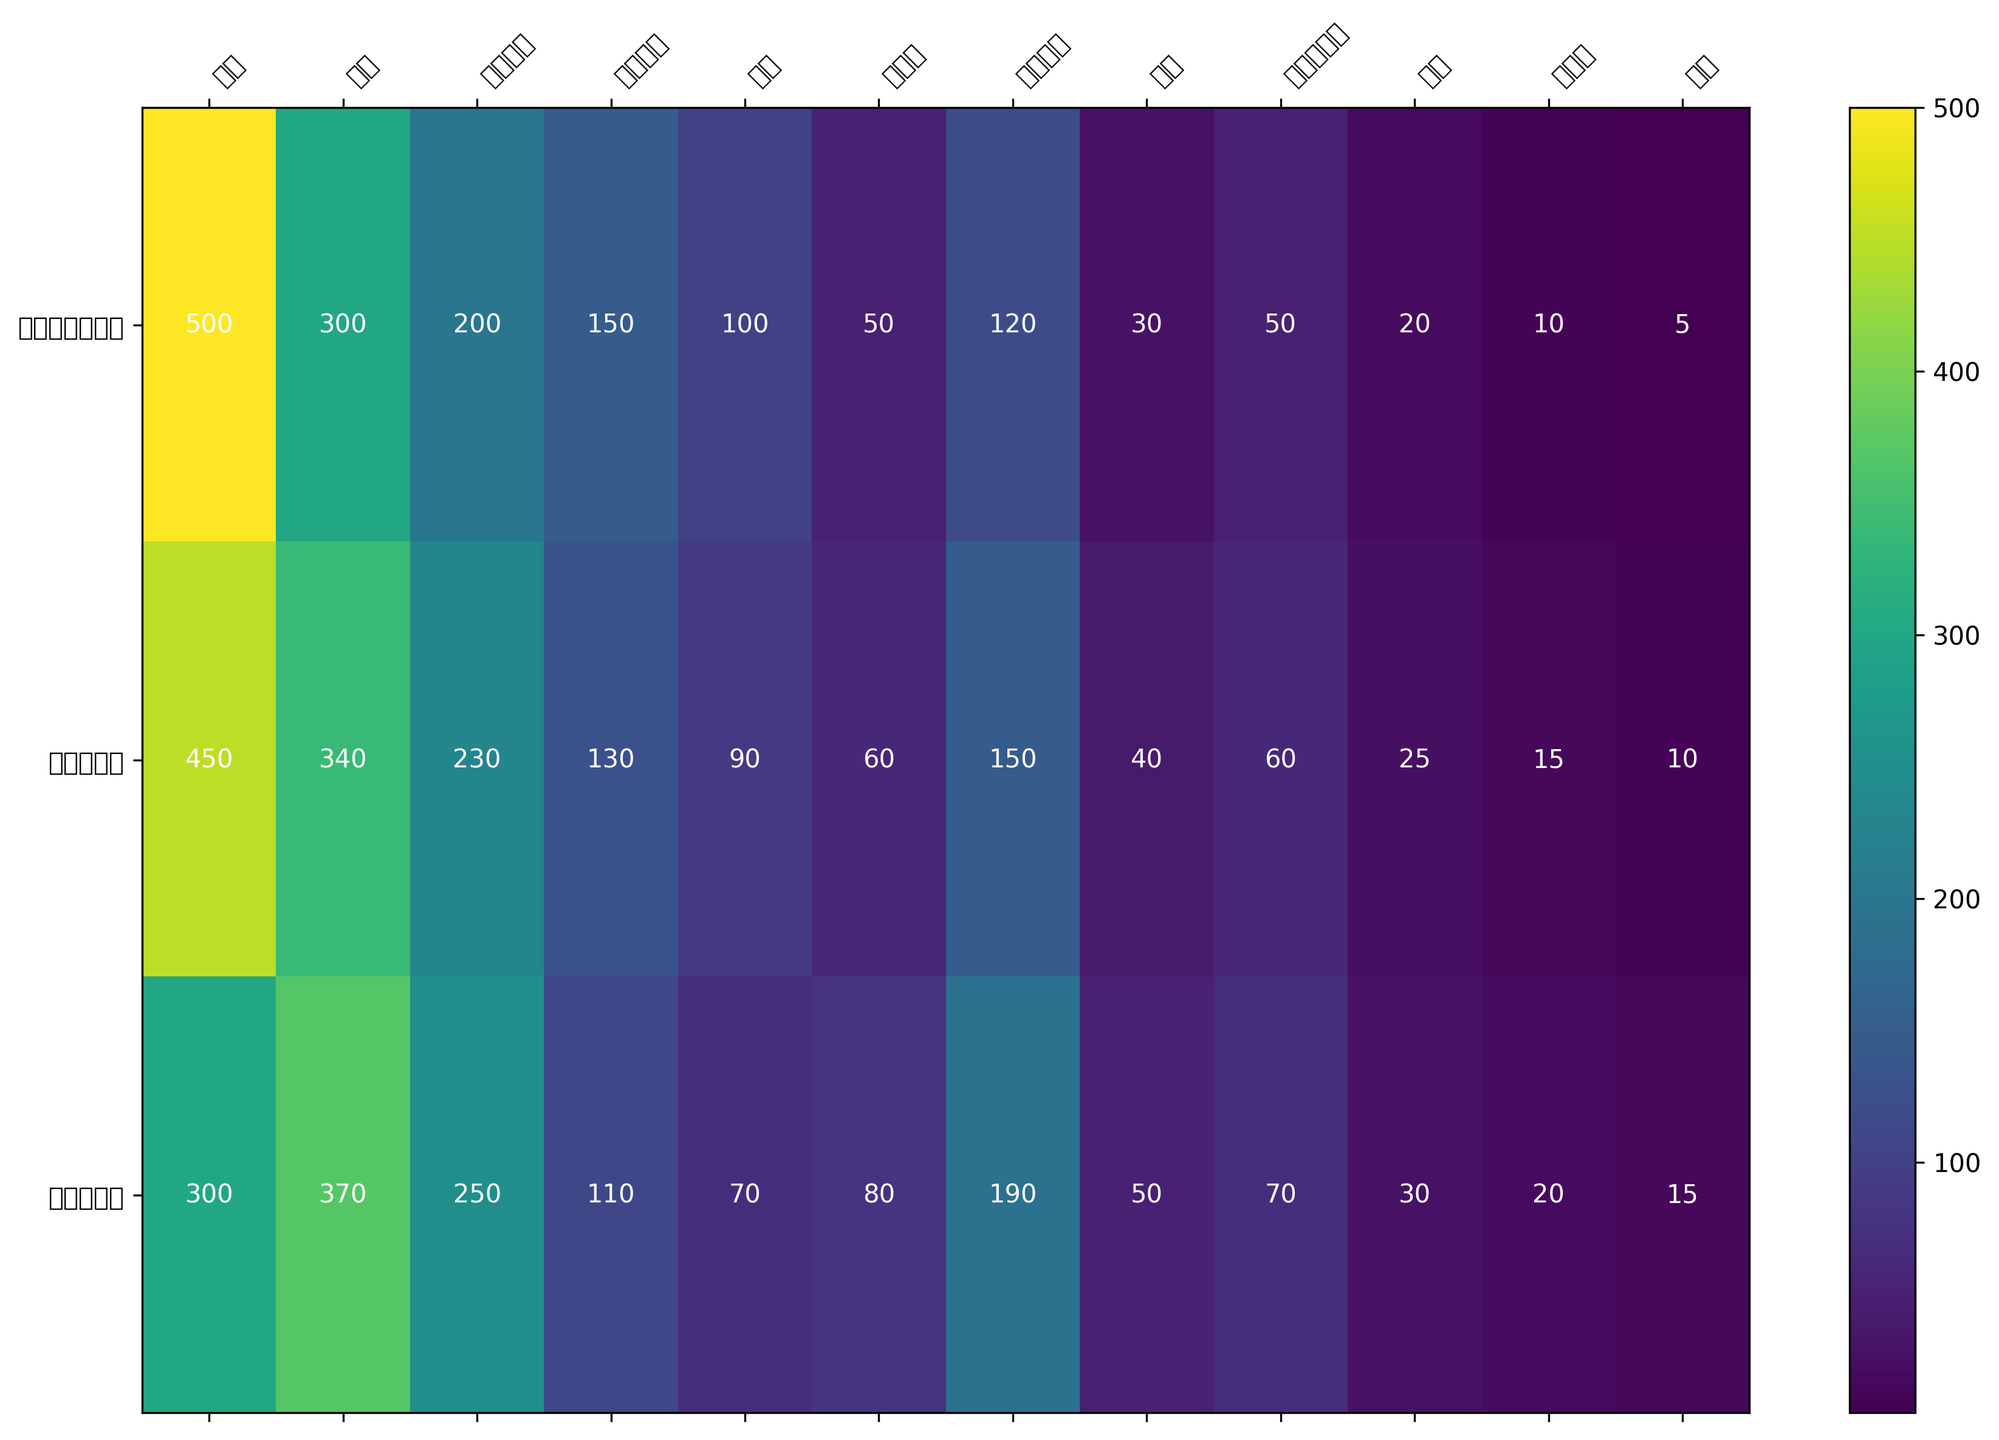哪一个行业在五年后的就业人数最多？ 观察热图中的颜色强度，科技公司在五年后人数为190，这比其他行业在五年后的人数多。
Answer: 科技公司 哪个行业在第一份工作与五年后的人数减少的最多？ 看热图上的数值和颜色对比，金融行业从500减少到300，减少了200人，这比其他行业减少的更多。
Answer: 金融 两年后非营利组织的就业人数与创业的就业人数相比，哪个更多？ 观察两年后的数据，非营利组织为60，创业为40，非营利组织的就业人数更多。
Answer: 非营利组织 咨询行业的就业人数在第一份工作、两年后和五年后各是多少？ 查找热图中的咨询行业对应的人数，第一份工作300，两年后340，五年后370。
Answer: 300，340，370 科技公司的就业人数在五年内的增长率是多少？ 科技公司五年的增长率计算为(190 - 120) / 120 = 0.583，转换为百分数是58.3%。
Answer: 58.3% 政府部门的就业人数在两年后和五年后的增幅是多少？ 政府部门两年后的增幅是(230 - 200) / 200 = 0.15，五年后的增幅是(250 - 200) / 200 = 0.25。
Answer: 15%，25% 教育行业在五年后的就业人数比创业多多少？ 教育行业在五年后有70人，创业有50人，教育比创业多20人。
Answer: 20 在第一份工作中，咨询和金融行业的总就业人数是多少？ 咨询行业第一份工作300人，金融行业500人，合计是300 + 500 = 800人。
Answer: 800 制造业在五年后的就业人数比第一份工作的人数多了多少？ 制造业第一份工作有50人，五年后有80人，多了80 - 50 = 30人。
Answer: 30 哪一个行业五年后的颜色最深？ 观察热图中五年后的颜色，最深的颜色是科技公司。
Answer: 科技公司 